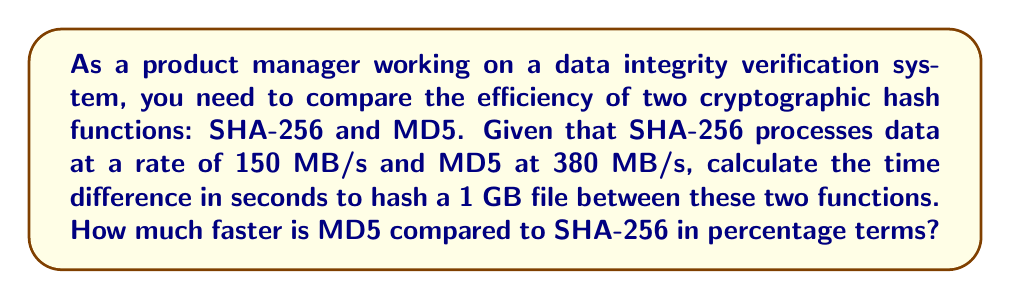What is the answer to this math problem? Let's approach this step-by-step:

1. Convert 1 GB to MB:
   $1 \text{ GB} = 1024 \text{ MB}$

2. Calculate time for SHA-256:
   $$t_{SHA-256} = \frac{1024 \text{ MB}}{150 \text{ MB/s}} = 6.827 \text{ seconds}$$

3. Calculate time for MD5:
   $$t_{MD5} = \frac{1024 \text{ MB}}{380 \text{ MB/s}} = 2.695 \text{ seconds}$$

4. Calculate the time difference:
   $$\Delta t = t_{SHA-256} - t_{MD5} = 6.827 - 2.695 = 4.132 \text{ seconds}$$

5. Calculate the percentage difference:
   $$\text{Percentage difference} = \frac{t_{SHA-256} - t_{MD5}}{t_{SHA-256}} \times 100\%$$
   $$= \frac{6.827 - 2.695}{6.827} \times 100\% = 60.52\%$$

Therefore, MD5 is 60.52% faster than SHA-256 for this task.
Answer: 4.132 seconds; 60.52% faster 